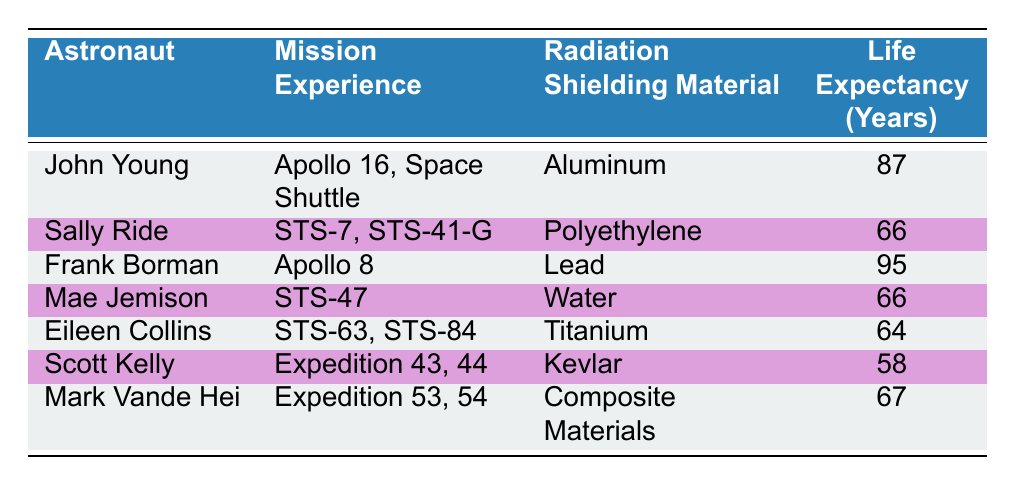What is the life expectancy of Frank Borman? Frank Borman's life expectancy is listed in the table under the "Life Expectancy (Years)" column, which shows a value of 95.
Answer: 95 Which astronaut had the highest life expectancy? By comparing the life expectancies listed for each astronaut, it is clear that Frank Borman has the highest life expectancy at 95 years.
Answer: Frank Borman Do astronauts using aluminum for radiation shielding have a life expectancy greater than 85 years? Looking at the life expectancy for John Young, who used aluminum, the value is 87 years, which is greater than 85.
Answer: Yes What is the average life expectancy of astronauts who used polyethylene and water for radiation shielding? The life expectancies for Sally Ride (66 years) and Mae Jemison (66 years) are both recorded. Their average is calculated as (66 + 66) / 2 = 66.
Answer: 66 Is it true that all astronauts with life expectancy above 80 years used lead or aluminum for shielding? Checking the life expectancies from the table, Frank Borman (95, lead) and John Young (87, aluminum) are indeed the only astronauts above 80 years, confirming the statement is true.
Answer: Yes How many astronauts have a life expectancy below 65 years? Reviewing the life expectancies, Scott Kelly (58 years) has the only record below 65 years, thus only one astronaut falls in this category.
Answer: 1 What is the difference in life expectancy between the least and most durable radiation shielding materials, based on the data? The materials with the highest life expectancy are lead (Frank Borman, 95 years) and the lowest is Kevlar (Scott Kelly, 58 years). The difference is calculated as 95 - 58 = 37.
Answer: 37 List the radiation shielding materials used by astronauts with life expectancy above 80 years. Frank Borman used lead and John Young used aluminum. These are the two materials associated with astronauts having a life expectancy above 80 years.
Answer: Lead, Aluminum How many astronauts in total used water or polyethylene as radiation shielding? The table lists Sally Ride using polyethylene and Mae Jemison using water, which sums up to 2 astronauts using these materials.
Answer: 2 